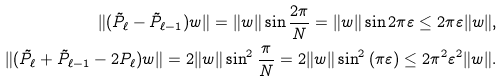<formula> <loc_0><loc_0><loc_500><loc_500>\| ( \tilde { P } _ { \ell } - \tilde { P } _ { \ell - 1 } ) w \| = \| w \| \sin \frac { 2 \pi } { N } = \| w \| \sin { 2 \pi \varepsilon } \leq 2 \pi \varepsilon \| w \| , \\ \| ( \tilde { P } _ { \ell } + \tilde { P } _ { \ell - 1 } - 2 P _ { \ell } ) w \| = 2 \| w \| \sin ^ { 2 } \frac { \pi } { N } = 2 \| w \| \sin ^ { 2 } { ( \pi \varepsilon ) } \leq 2 \pi ^ { 2 } \varepsilon ^ { 2 } \| w \| .</formula> 